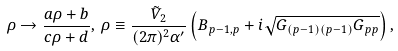<formula> <loc_0><loc_0><loc_500><loc_500>\rho \to \frac { a \rho + b } { c \rho + d } , \, \rho \equiv \frac { { \tilde { V } } _ { 2 } } { ( 2 \pi ) ^ { 2 } \alpha ^ { \prime } } \left ( B _ { p - 1 , p } + i \sqrt { G _ { ( p - 1 ) ( p - 1 ) } G _ { p p } } \right ) ,</formula> 